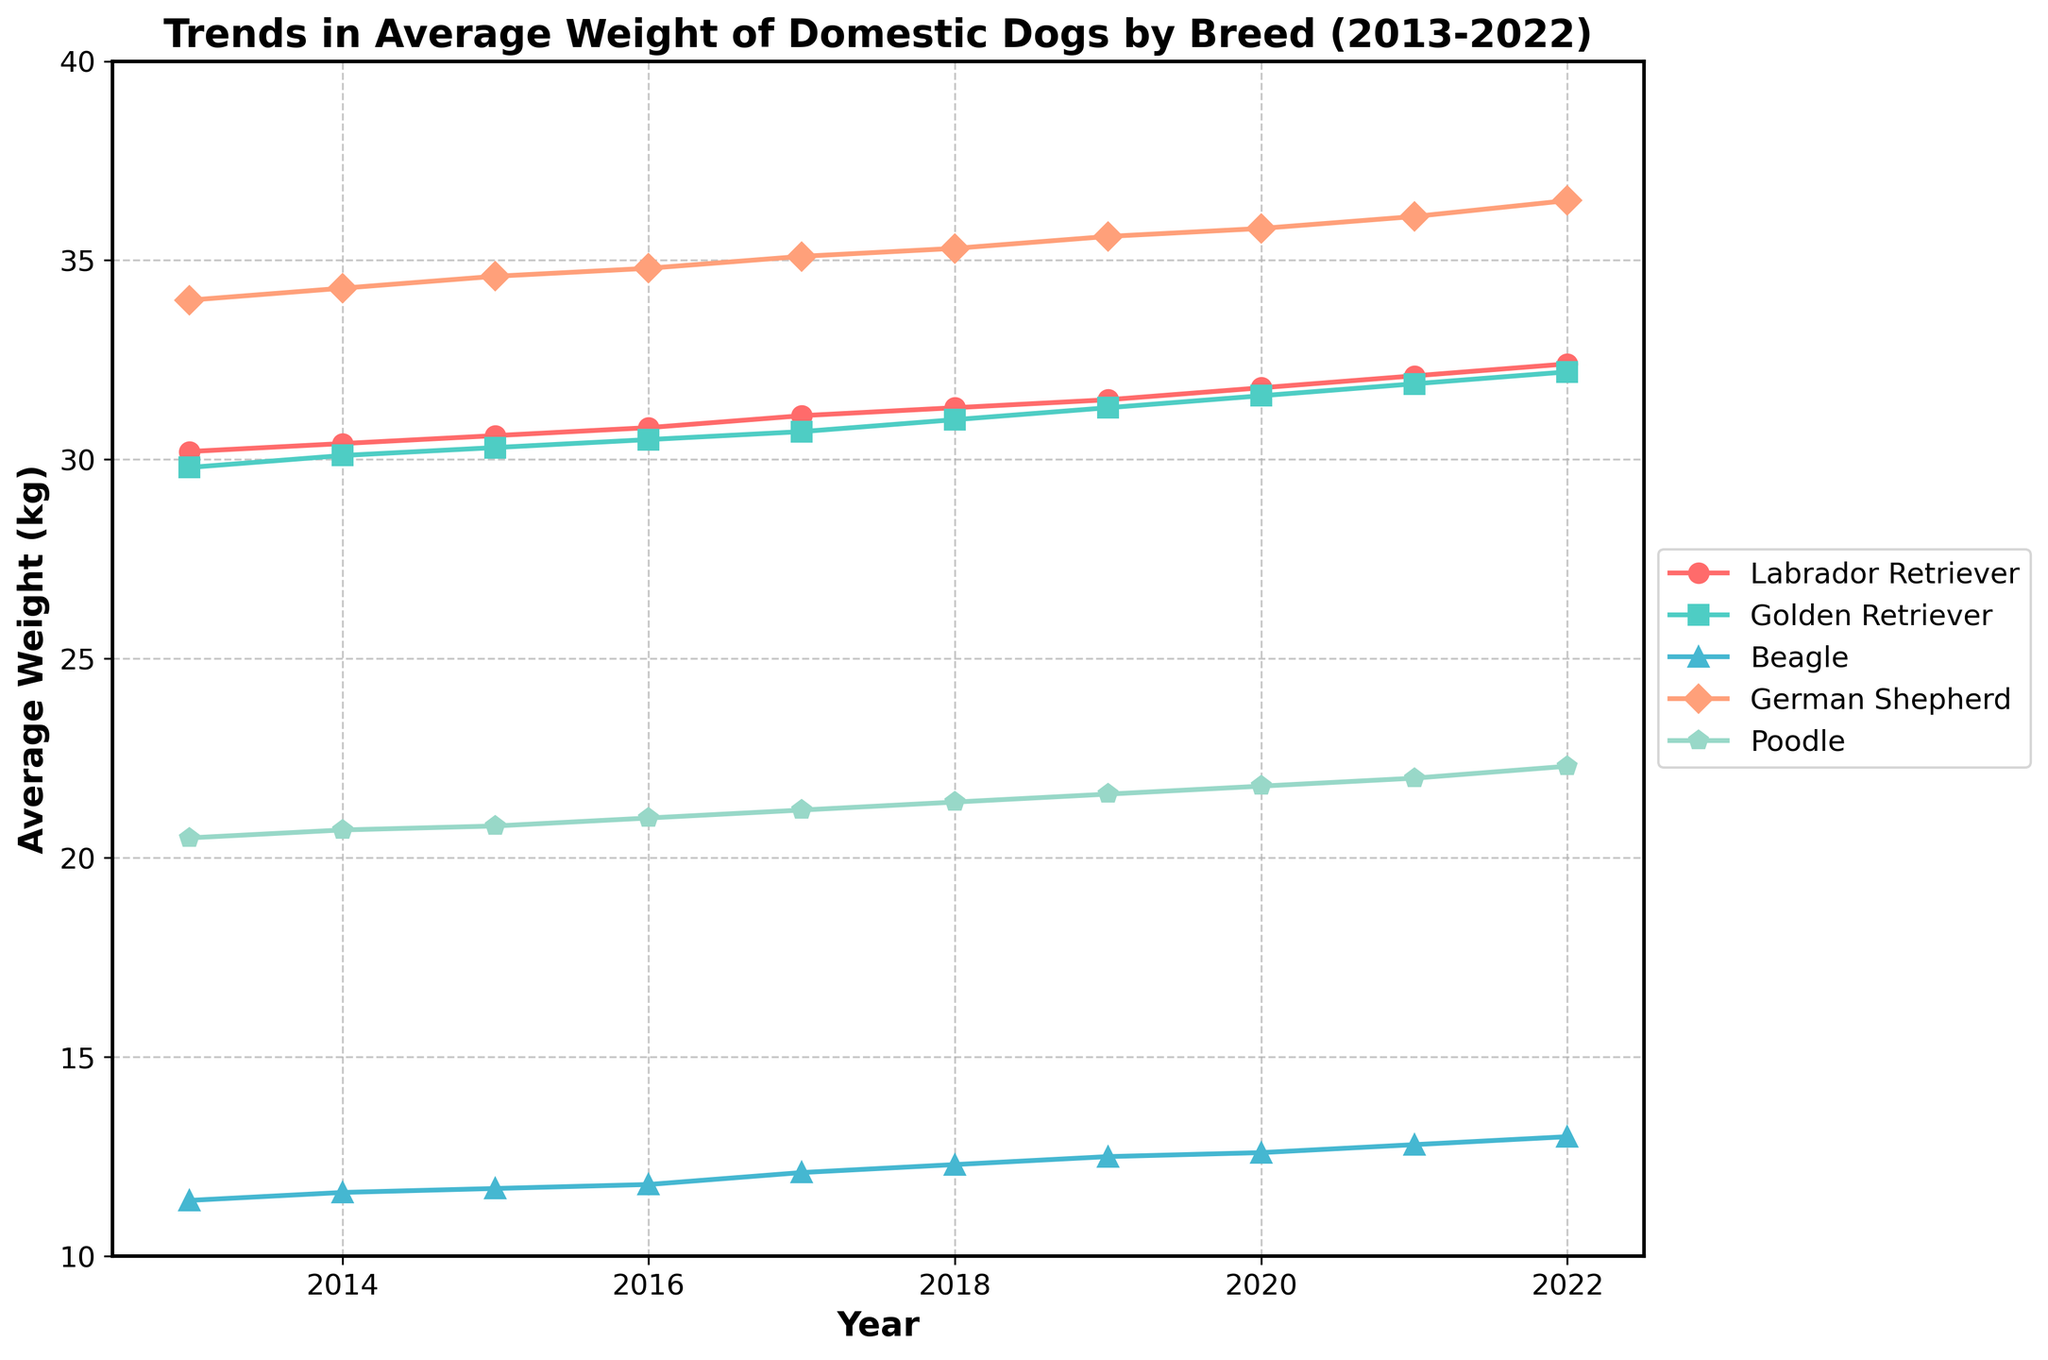What is the title of the plot? The title is usually located at the top of the plot and describes what the plot is about. Here, the title clearly states the focus of the plot.
Answer: Trends in Average Weight of Domestic Dogs by Breed (2013-2022) What are the years shown on the x-axis? The x-axis represents the time period over which the data is collected. By looking at the ticks on the x-axis, you can see the specific years included.
Answer: 2013 to 2022 Which breed has the highest average weight in 2022? To find this, look at the data points for 2022 and compare the average weights of all breeds. The breed with the highest data point on the y-axis in 2022 will be the answer.
Answer: German Shepherd What is the overall trend for the Labrador Retriever's average weight over the past decade? To determine the overall trend, observe the series of data points for the Labrador Retriever from 2013 to 2022. You can see if the line is increasing, decreasing, or staying constant.
Answer: Increasing Which breed shows the least variation in average weight over the past decade? To identify the breed with the least variation, observe the spread of data points for each breed. The breed with the smallest changes in y-values across the timeline has the least variation.
Answer: Beagle Between which years did the Poodle experience the most significant increase in average weight? Look for the steepest slope in the Poodle's line. The segment of the line with the highest upward angle indicates the period of the most significant increase.
Answer: 2021 to 2022 How many breeds are shown in the plot? By counting the distinct legend entries or the unique lines on the plot, you can determine the number of breeds.
Answer: 5 Did any breed's average weight decrease at any point over the decade? Analyze each line and check for any downward slopes, which would indicate a decrease in average weight at some point.
Answer: No Which two breeds have a similar average weight trend over the years? Compare the lines for different breeds. Lines that run parallel to each other or overlap significantly indicate similar trends in average weight.
Answer: Labrador Retriever and Golden Retriever How much did the average weight of the Beagle increase from 2013 to 2022? To find this, subtract the 2013 average weight from the 2022 average weight for the Beagle. The difference gives the total increase over the period.
Answer: 1.6 kg 